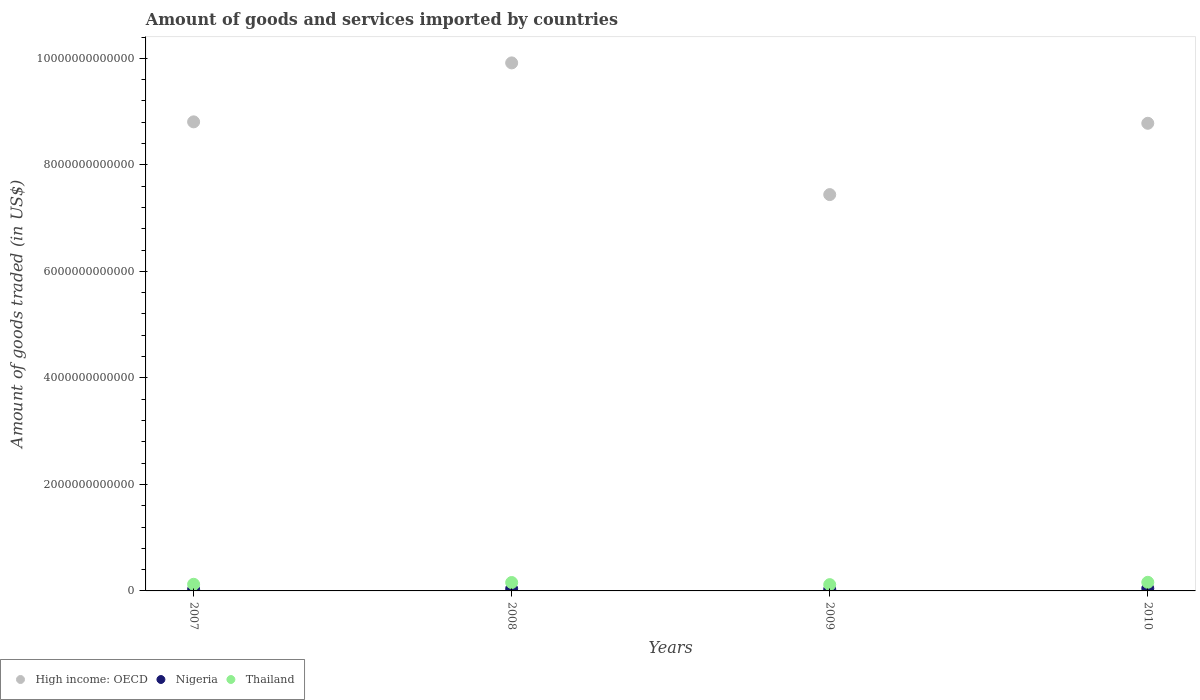What is the total amount of goods and services imported in Thailand in 2009?
Keep it short and to the point. 1.18e+11. Across all years, what is the maximum total amount of goods and services imported in Thailand?
Your response must be concise. 1.62e+11. Across all years, what is the minimum total amount of goods and services imported in Thailand?
Keep it short and to the point. 1.18e+11. In which year was the total amount of goods and services imported in Nigeria minimum?
Provide a succinct answer. 2007. What is the total total amount of goods and services imported in Nigeria in the graph?
Give a very brief answer. 1.45e+11. What is the difference between the total amount of goods and services imported in High income: OECD in 2007 and that in 2010?
Your answer should be compact. 2.68e+1. What is the difference between the total amount of goods and services imported in Nigeria in 2008 and the total amount of goods and services imported in High income: OECD in 2007?
Your answer should be compact. -8.77e+12. What is the average total amount of goods and services imported in High income: OECD per year?
Your answer should be compact. 8.74e+12. In the year 2010, what is the difference between the total amount of goods and services imported in Thailand and total amount of goods and services imported in Nigeria?
Provide a succinct answer. 1.16e+11. What is the ratio of the total amount of goods and services imported in Thailand in 2007 to that in 2010?
Your response must be concise. 0.77. Is the total amount of goods and services imported in Thailand in 2009 less than that in 2010?
Give a very brief answer. Yes. What is the difference between the highest and the second highest total amount of goods and services imported in Thailand?
Keep it short and to the point. 4.11e+09. What is the difference between the highest and the lowest total amount of goods and services imported in High income: OECD?
Offer a very short reply. 2.47e+12. Is the sum of the total amount of goods and services imported in High income: OECD in 2008 and 2009 greater than the maximum total amount of goods and services imported in Thailand across all years?
Your answer should be very brief. Yes. Is it the case that in every year, the sum of the total amount of goods and services imported in Nigeria and total amount of goods and services imported in High income: OECD  is greater than the total amount of goods and services imported in Thailand?
Make the answer very short. Yes. How many years are there in the graph?
Your answer should be compact. 4. What is the difference between two consecutive major ticks on the Y-axis?
Your response must be concise. 2.00e+12. Are the values on the major ticks of Y-axis written in scientific E-notation?
Give a very brief answer. No. Does the graph contain any zero values?
Provide a short and direct response. No. What is the title of the graph?
Keep it short and to the point. Amount of goods and services imported by countries. What is the label or title of the Y-axis?
Ensure brevity in your answer.  Amount of goods traded (in US$). What is the Amount of goods traded (in US$) in High income: OECD in 2007?
Make the answer very short. 8.81e+12. What is the Amount of goods traded (in US$) of Nigeria in 2007?
Ensure brevity in your answer.  2.83e+1. What is the Amount of goods traded (in US$) of Thailand in 2007?
Offer a very short reply. 1.25e+11. What is the Amount of goods traded (in US$) of High income: OECD in 2008?
Offer a very short reply. 9.91e+12. What is the Amount of goods traded (in US$) in Nigeria in 2008?
Make the answer very short. 3.98e+1. What is the Amount of goods traded (in US$) in Thailand in 2008?
Make the answer very short. 1.58e+11. What is the Amount of goods traded (in US$) in High income: OECD in 2009?
Ensure brevity in your answer.  7.44e+12. What is the Amount of goods traded (in US$) of Nigeria in 2009?
Keep it short and to the point. 3.08e+1. What is the Amount of goods traded (in US$) of Thailand in 2009?
Provide a short and direct response. 1.18e+11. What is the Amount of goods traded (in US$) in High income: OECD in 2010?
Offer a terse response. 8.78e+12. What is the Amount of goods traded (in US$) in Nigeria in 2010?
Offer a terse response. 4.64e+1. What is the Amount of goods traded (in US$) in Thailand in 2010?
Provide a short and direct response. 1.62e+11. Across all years, what is the maximum Amount of goods traded (in US$) of High income: OECD?
Give a very brief answer. 9.91e+12. Across all years, what is the maximum Amount of goods traded (in US$) of Nigeria?
Ensure brevity in your answer.  4.64e+1. Across all years, what is the maximum Amount of goods traded (in US$) of Thailand?
Your answer should be compact. 1.62e+11. Across all years, what is the minimum Amount of goods traded (in US$) of High income: OECD?
Make the answer very short. 7.44e+12. Across all years, what is the minimum Amount of goods traded (in US$) of Nigeria?
Give a very brief answer. 2.83e+1. Across all years, what is the minimum Amount of goods traded (in US$) in Thailand?
Keep it short and to the point. 1.18e+11. What is the total Amount of goods traded (in US$) of High income: OECD in the graph?
Give a very brief answer. 3.49e+13. What is the total Amount of goods traded (in US$) in Nigeria in the graph?
Provide a short and direct response. 1.45e+11. What is the total Amount of goods traded (in US$) of Thailand in the graph?
Provide a short and direct response. 5.63e+11. What is the difference between the Amount of goods traded (in US$) in High income: OECD in 2007 and that in 2008?
Offer a terse response. -1.11e+12. What is the difference between the Amount of goods traded (in US$) in Nigeria in 2007 and that in 2008?
Offer a very short reply. -1.16e+1. What is the difference between the Amount of goods traded (in US$) of Thailand in 2007 and that in 2008?
Your answer should be very brief. -3.32e+1. What is the difference between the Amount of goods traded (in US$) in High income: OECD in 2007 and that in 2009?
Offer a terse response. 1.37e+12. What is the difference between the Amount of goods traded (in US$) of Nigeria in 2007 and that in 2009?
Provide a succinct answer. -2.49e+09. What is the difference between the Amount of goods traded (in US$) of Thailand in 2007 and that in 2009?
Provide a succinct answer. 6.43e+09. What is the difference between the Amount of goods traded (in US$) of High income: OECD in 2007 and that in 2010?
Ensure brevity in your answer.  2.68e+1. What is the difference between the Amount of goods traded (in US$) in Nigeria in 2007 and that in 2010?
Your response must be concise. -1.81e+1. What is the difference between the Amount of goods traded (in US$) in Thailand in 2007 and that in 2010?
Offer a terse response. -3.73e+1. What is the difference between the Amount of goods traded (in US$) in High income: OECD in 2008 and that in 2009?
Your answer should be compact. 2.47e+12. What is the difference between the Amount of goods traded (in US$) in Nigeria in 2008 and that in 2009?
Ensure brevity in your answer.  9.06e+09. What is the difference between the Amount of goods traded (in US$) in Thailand in 2008 and that in 2009?
Provide a short and direct response. 3.96e+1. What is the difference between the Amount of goods traded (in US$) in High income: OECD in 2008 and that in 2010?
Give a very brief answer. 1.13e+12. What is the difference between the Amount of goods traded (in US$) in Nigeria in 2008 and that in 2010?
Offer a very short reply. -6.53e+09. What is the difference between the Amount of goods traded (in US$) in Thailand in 2008 and that in 2010?
Your response must be concise. -4.11e+09. What is the difference between the Amount of goods traded (in US$) in High income: OECD in 2009 and that in 2010?
Provide a succinct answer. -1.34e+12. What is the difference between the Amount of goods traded (in US$) of Nigeria in 2009 and that in 2010?
Your answer should be compact. -1.56e+1. What is the difference between the Amount of goods traded (in US$) of Thailand in 2009 and that in 2010?
Your response must be concise. -4.38e+1. What is the difference between the Amount of goods traded (in US$) in High income: OECD in 2007 and the Amount of goods traded (in US$) in Nigeria in 2008?
Your answer should be compact. 8.77e+12. What is the difference between the Amount of goods traded (in US$) in High income: OECD in 2007 and the Amount of goods traded (in US$) in Thailand in 2008?
Your response must be concise. 8.65e+12. What is the difference between the Amount of goods traded (in US$) of Nigeria in 2007 and the Amount of goods traded (in US$) of Thailand in 2008?
Make the answer very short. -1.30e+11. What is the difference between the Amount of goods traded (in US$) of High income: OECD in 2007 and the Amount of goods traded (in US$) of Nigeria in 2009?
Give a very brief answer. 8.78e+12. What is the difference between the Amount of goods traded (in US$) of High income: OECD in 2007 and the Amount of goods traded (in US$) of Thailand in 2009?
Make the answer very short. 8.69e+12. What is the difference between the Amount of goods traded (in US$) of Nigeria in 2007 and the Amount of goods traded (in US$) of Thailand in 2009?
Keep it short and to the point. -8.99e+1. What is the difference between the Amount of goods traded (in US$) in High income: OECD in 2007 and the Amount of goods traded (in US$) in Nigeria in 2010?
Provide a succinct answer. 8.76e+12. What is the difference between the Amount of goods traded (in US$) in High income: OECD in 2007 and the Amount of goods traded (in US$) in Thailand in 2010?
Offer a very short reply. 8.65e+12. What is the difference between the Amount of goods traded (in US$) in Nigeria in 2007 and the Amount of goods traded (in US$) in Thailand in 2010?
Provide a succinct answer. -1.34e+11. What is the difference between the Amount of goods traded (in US$) of High income: OECD in 2008 and the Amount of goods traded (in US$) of Nigeria in 2009?
Your answer should be compact. 9.88e+12. What is the difference between the Amount of goods traded (in US$) of High income: OECD in 2008 and the Amount of goods traded (in US$) of Thailand in 2009?
Give a very brief answer. 9.80e+12. What is the difference between the Amount of goods traded (in US$) of Nigeria in 2008 and the Amount of goods traded (in US$) of Thailand in 2009?
Provide a succinct answer. -7.83e+1. What is the difference between the Amount of goods traded (in US$) in High income: OECD in 2008 and the Amount of goods traded (in US$) in Nigeria in 2010?
Your response must be concise. 9.87e+12. What is the difference between the Amount of goods traded (in US$) of High income: OECD in 2008 and the Amount of goods traded (in US$) of Thailand in 2010?
Offer a terse response. 9.75e+12. What is the difference between the Amount of goods traded (in US$) in Nigeria in 2008 and the Amount of goods traded (in US$) in Thailand in 2010?
Keep it short and to the point. -1.22e+11. What is the difference between the Amount of goods traded (in US$) of High income: OECD in 2009 and the Amount of goods traded (in US$) of Nigeria in 2010?
Provide a short and direct response. 7.40e+12. What is the difference between the Amount of goods traded (in US$) in High income: OECD in 2009 and the Amount of goods traded (in US$) in Thailand in 2010?
Ensure brevity in your answer.  7.28e+12. What is the difference between the Amount of goods traded (in US$) of Nigeria in 2009 and the Amount of goods traded (in US$) of Thailand in 2010?
Ensure brevity in your answer.  -1.31e+11. What is the average Amount of goods traded (in US$) in High income: OECD per year?
Provide a short and direct response. 8.74e+12. What is the average Amount of goods traded (in US$) in Nigeria per year?
Your response must be concise. 3.63e+1. What is the average Amount of goods traded (in US$) of Thailand per year?
Keep it short and to the point. 1.41e+11. In the year 2007, what is the difference between the Amount of goods traded (in US$) in High income: OECD and Amount of goods traded (in US$) in Nigeria?
Offer a very short reply. 8.78e+12. In the year 2007, what is the difference between the Amount of goods traded (in US$) in High income: OECD and Amount of goods traded (in US$) in Thailand?
Give a very brief answer. 8.68e+12. In the year 2007, what is the difference between the Amount of goods traded (in US$) of Nigeria and Amount of goods traded (in US$) of Thailand?
Ensure brevity in your answer.  -9.63e+1. In the year 2008, what is the difference between the Amount of goods traded (in US$) of High income: OECD and Amount of goods traded (in US$) of Nigeria?
Ensure brevity in your answer.  9.87e+12. In the year 2008, what is the difference between the Amount of goods traded (in US$) of High income: OECD and Amount of goods traded (in US$) of Thailand?
Offer a terse response. 9.76e+12. In the year 2008, what is the difference between the Amount of goods traded (in US$) of Nigeria and Amount of goods traded (in US$) of Thailand?
Offer a very short reply. -1.18e+11. In the year 2009, what is the difference between the Amount of goods traded (in US$) of High income: OECD and Amount of goods traded (in US$) of Nigeria?
Offer a very short reply. 7.41e+12. In the year 2009, what is the difference between the Amount of goods traded (in US$) of High income: OECD and Amount of goods traded (in US$) of Thailand?
Keep it short and to the point. 7.32e+12. In the year 2009, what is the difference between the Amount of goods traded (in US$) of Nigeria and Amount of goods traded (in US$) of Thailand?
Your response must be concise. -8.74e+1. In the year 2010, what is the difference between the Amount of goods traded (in US$) in High income: OECD and Amount of goods traded (in US$) in Nigeria?
Give a very brief answer. 8.73e+12. In the year 2010, what is the difference between the Amount of goods traded (in US$) in High income: OECD and Amount of goods traded (in US$) in Thailand?
Make the answer very short. 8.62e+12. In the year 2010, what is the difference between the Amount of goods traded (in US$) of Nigeria and Amount of goods traded (in US$) of Thailand?
Ensure brevity in your answer.  -1.16e+11. What is the ratio of the Amount of goods traded (in US$) of High income: OECD in 2007 to that in 2008?
Give a very brief answer. 0.89. What is the ratio of the Amount of goods traded (in US$) in Nigeria in 2007 to that in 2008?
Keep it short and to the point. 0.71. What is the ratio of the Amount of goods traded (in US$) of Thailand in 2007 to that in 2008?
Provide a succinct answer. 0.79. What is the ratio of the Amount of goods traded (in US$) of High income: OECD in 2007 to that in 2009?
Give a very brief answer. 1.18. What is the ratio of the Amount of goods traded (in US$) in Nigeria in 2007 to that in 2009?
Your answer should be compact. 0.92. What is the ratio of the Amount of goods traded (in US$) in Thailand in 2007 to that in 2009?
Your response must be concise. 1.05. What is the ratio of the Amount of goods traded (in US$) in Nigeria in 2007 to that in 2010?
Your answer should be compact. 0.61. What is the ratio of the Amount of goods traded (in US$) of Thailand in 2007 to that in 2010?
Your answer should be very brief. 0.77. What is the ratio of the Amount of goods traded (in US$) in High income: OECD in 2008 to that in 2009?
Provide a succinct answer. 1.33. What is the ratio of the Amount of goods traded (in US$) in Nigeria in 2008 to that in 2009?
Offer a terse response. 1.29. What is the ratio of the Amount of goods traded (in US$) of Thailand in 2008 to that in 2009?
Your response must be concise. 1.34. What is the ratio of the Amount of goods traded (in US$) of High income: OECD in 2008 to that in 2010?
Offer a very short reply. 1.13. What is the ratio of the Amount of goods traded (in US$) of Nigeria in 2008 to that in 2010?
Your answer should be compact. 0.86. What is the ratio of the Amount of goods traded (in US$) in Thailand in 2008 to that in 2010?
Provide a short and direct response. 0.97. What is the ratio of the Amount of goods traded (in US$) in High income: OECD in 2009 to that in 2010?
Your answer should be very brief. 0.85. What is the ratio of the Amount of goods traded (in US$) in Nigeria in 2009 to that in 2010?
Your response must be concise. 0.66. What is the ratio of the Amount of goods traded (in US$) in Thailand in 2009 to that in 2010?
Offer a terse response. 0.73. What is the difference between the highest and the second highest Amount of goods traded (in US$) of High income: OECD?
Ensure brevity in your answer.  1.11e+12. What is the difference between the highest and the second highest Amount of goods traded (in US$) of Nigeria?
Provide a succinct answer. 6.53e+09. What is the difference between the highest and the second highest Amount of goods traded (in US$) of Thailand?
Make the answer very short. 4.11e+09. What is the difference between the highest and the lowest Amount of goods traded (in US$) of High income: OECD?
Give a very brief answer. 2.47e+12. What is the difference between the highest and the lowest Amount of goods traded (in US$) in Nigeria?
Offer a terse response. 1.81e+1. What is the difference between the highest and the lowest Amount of goods traded (in US$) of Thailand?
Offer a terse response. 4.38e+1. 